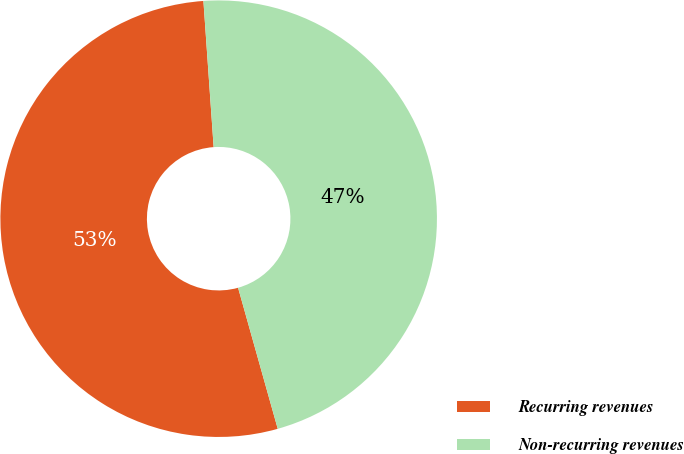Convert chart. <chart><loc_0><loc_0><loc_500><loc_500><pie_chart><fcel>Recurring revenues<fcel>Non-recurring revenues<nl><fcel>53.25%<fcel>46.75%<nl></chart> 